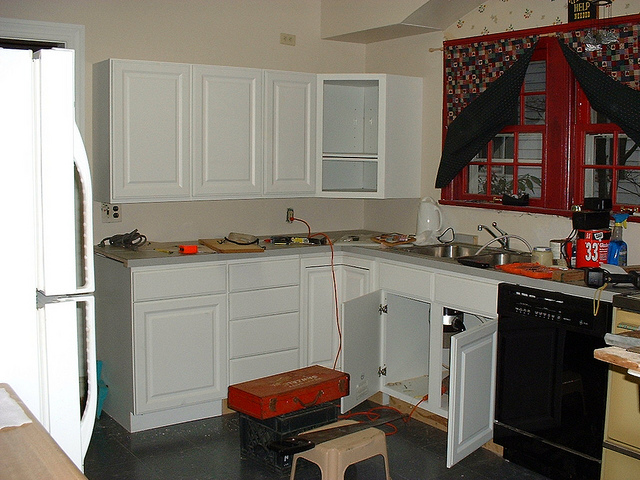Please extract the text content from this image. HELP 33 